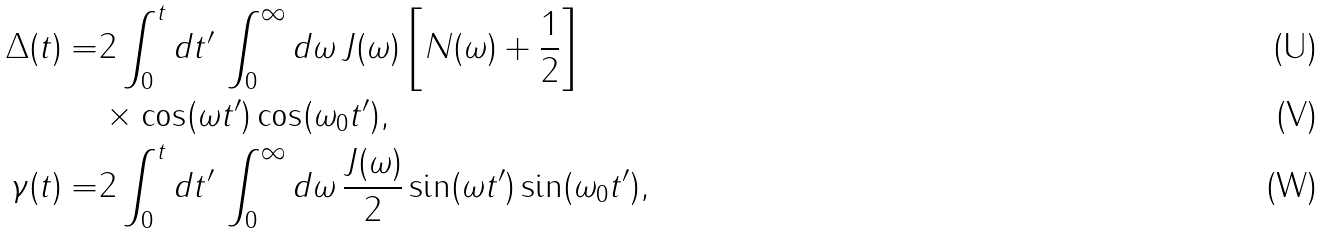Convert formula to latex. <formula><loc_0><loc_0><loc_500><loc_500>\Delta ( t ) = & 2 \int _ { 0 } ^ { t } d t ^ { \prime } \, \int _ { 0 } ^ { \infty } d \omega \, J ( \omega ) \left [ N ( \omega ) + \frac { 1 } { 2 } \right ] \\ & \times \cos ( \omega t ^ { \prime } ) \cos ( \omega _ { 0 } t ^ { \prime } ) , \\ \gamma ( t ) = & 2 \int _ { 0 } ^ { t } d t ^ { \prime } \, \int _ { 0 } ^ { \infty } d \omega \, \frac { J ( \omega ) } { 2 } \sin ( \omega t ^ { \prime } ) \sin ( \omega _ { 0 } t ^ { \prime } ) ,</formula> 